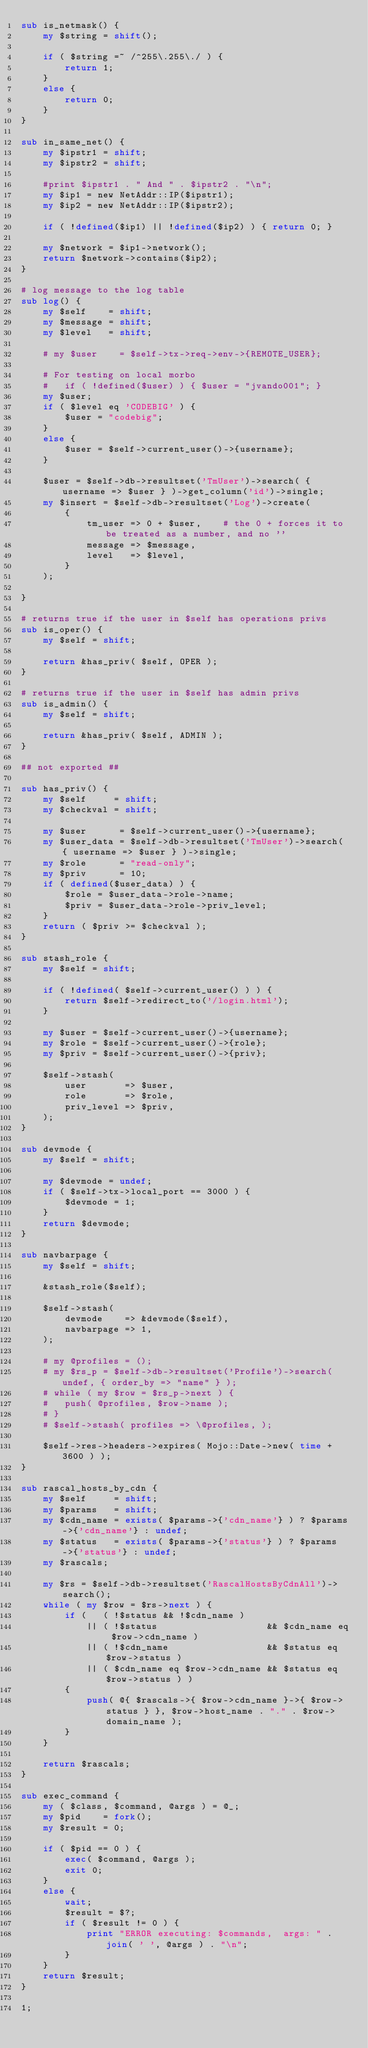Convert code to text. <code><loc_0><loc_0><loc_500><loc_500><_Perl_>sub is_netmask() {
	my $string = shift();

	if ( $string =~ /^255\.255\./ ) {
		return 1;
	}
	else {
		return 0;
	}
}

sub in_same_net() {
	my $ipstr1 = shift;
	my $ipstr2 = shift;

	#print $ipstr1 . " And " . $ipstr2 . "\n";
	my $ip1 = new NetAddr::IP($ipstr1);
	my $ip2 = new NetAddr::IP($ipstr2);

	if ( !defined($ip1) || !defined($ip2) ) { return 0; }

	my $network = $ip1->network();
	return $network->contains($ip2);
}

# log message to the log table
sub log() {
	my $self    = shift;
	my $message = shift;
	my $level   = shift;

	# my $user    = $self->tx->req->env->{REMOTE_USER};

	# For testing on local morbo
	#	if ( !defined($user) ) { $user = "jvando001"; }
	my $user;
	if ( $level eq 'CODEBIG' ) {
		$user = "codebig";
	}
	else {
		$user = $self->current_user()->{username};
	}

	$user = $self->db->resultset('TmUser')->search( { username => $user } )->get_column('id')->single;
	my $insert = $self->db->resultset('Log')->create(
		{
			tm_user => 0 + $user,    # the 0 + forces it to be treated as a number, and no ''
			message => $message,
			level   => $level,
		}
	);

}

# returns true if the user in $self has operations privs
sub is_oper() {
	my $self = shift;

	return &has_priv( $self, OPER );
}

# returns true if the user in $self has admin privs
sub is_admin() {
	my $self = shift;

	return &has_priv( $self, ADMIN );
}

## not exported ##

sub has_priv() {
	my $self     = shift;
	my $checkval = shift;

	my $user      = $self->current_user()->{username};
	my $user_data = $self->db->resultset('TmUser')->search( { username => $user } )->single;
	my $role      = "read-only";
	my $priv      = 10;
	if ( defined($user_data) ) {
		$role = $user_data->role->name;
		$priv = $user_data->role->priv_level;
	}
	return ( $priv >= $checkval );
}

sub stash_role {
	my $self = shift;

	if ( !defined( $self->current_user() ) ) {
		return $self->redirect_to('/login.html');
	}

	my $user = $self->current_user()->{username};
	my $role = $self->current_user()->{role};
	my $priv = $self->current_user()->{priv};

	$self->stash(
		user       => $user,
		role       => $role,
		priv_level => $priv,
	);
}

sub devmode {
	my $self = shift;

	my $devmode = undef;
	if ( $self->tx->local_port == 3000 ) {
		$devmode = 1;
	}
	return $devmode;
}

sub navbarpage {
	my $self = shift;

	&stash_role($self);

	$self->stash(
		devmode    => &devmode($self),
		navbarpage => 1,
	);

	# my @profiles = ();
	# my $rs_p = $self->db->resultset('Profile')->search( undef, { order_by => "name" } );
	# while ( my $row = $rs_p->next ) {
	# 	push( @profiles, $row->name );
	# }
	# $self->stash( profiles => \@profiles, );

	$self->res->headers->expires( Mojo::Date->new( time + 3600 ) );
}

sub rascal_hosts_by_cdn {
	my $self     = shift;
	my $params   = shift;
	my $cdn_name = exists( $params->{'cdn_name'} ) ? $params->{'cdn_name'} : undef;
	my $status   = exists( $params->{'status'} ) ? $params->{'status'} : undef;
	my $rascals;

	my $rs = $self->db->resultset('RascalHostsByCdnAll')->search();
	while ( my $row = $rs->next ) {
		if (   ( !$status && !$cdn_name )
			|| ( !$status                    && $cdn_name eq $row->cdn_name )
			|| ( !$cdn_name                  && $status eq $row->status )
			|| ( $cdn_name eq $row->cdn_name && $status eq $row->status ) )
		{
			push( @{ $rascals->{ $row->cdn_name }->{ $row->status } }, $row->host_name . "." . $row->domain_name );
		}
	}

	return $rascals;
}

sub exec_command {
	my ( $class, $command, @args ) = @_;
	my $pid    = fork();
	my $result = 0;

	if ( $pid == 0 ) {
		exec( $command, @args );
		exit 0;
	}
	else {
		wait;
		$result = $?;
		if ( $result != 0 ) {
			print "ERROR executing: $commands,  args: " . join( ' ', @args ) . "\n";
		}
	}
	return $result;
}

1;
</code> 